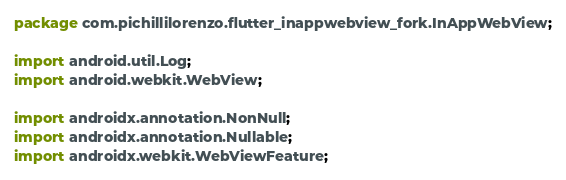Convert code to text. <code><loc_0><loc_0><loc_500><loc_500><_Java_>package com.pichillilorenzo.flutter_inappwebview_fork.InAppWebView;

import android.util.Log;
import android.webkit.WebView;

import androidx.annotation.NonNull;
import androidx.annotation.Nullable;
import androidx.webkit.WebViewFeature;</code> 